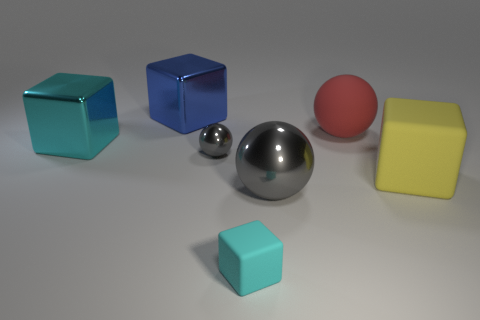Subtract all small gray balls. How many balls are left? 2 Subtract all yellow cylinders. How many gray spheres are left? 2 Subtract all blue cubes. How many cubes are left? 3 Add 3 big yellow objects. How many objects exist? 10 Subtract all cubes. How many objects are left? 3 Subtract all gray cubes. Subtract all brown cylinders. How many cubes are left? 4 Subtract 0 purple blocks. How many objects are left? 7 Subtract all cyan metal objects. Subtract all brown rubber cylinders. How many objects are left? 6 Add 7 gray metallic objects. How many gray metallic objects are left? 9 Add 7 shiny balls. How many shiny balls exist? 9 